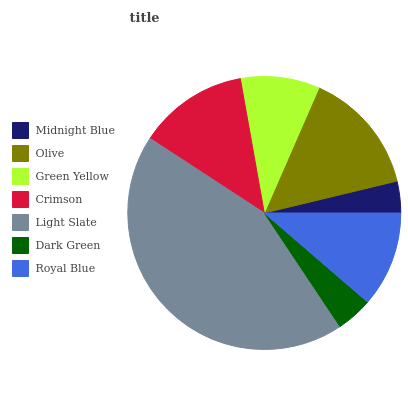Is Midnight Blue the minimum?
Answer yes or no. Yes. Is Light Slate the maximum?
Answer yes or no. Yes. Is Olive the minimum?
Answer yes or no. No. Is Olive the maximum?
Answer yes or no. No. Is Olive greater than Midnight Blue?
Answer yes or no. Yes. Is Midnight Blue less than Olive?
Answer yes or no. Yes. Is Midnight Blue greater than Olive?
Answer yes or no. No. Is Olive less than Midnight Blue?
Answer yes or no. No. Is Royal Blue the high median?
Answer yes or no. Yes. Is Royal Blue the low median?
Answer yes or no. Yes. Is Midnight Blue the high median?
Answer yes or no. No. Is Green Yellow the low median?
Answer yes or no. No. 